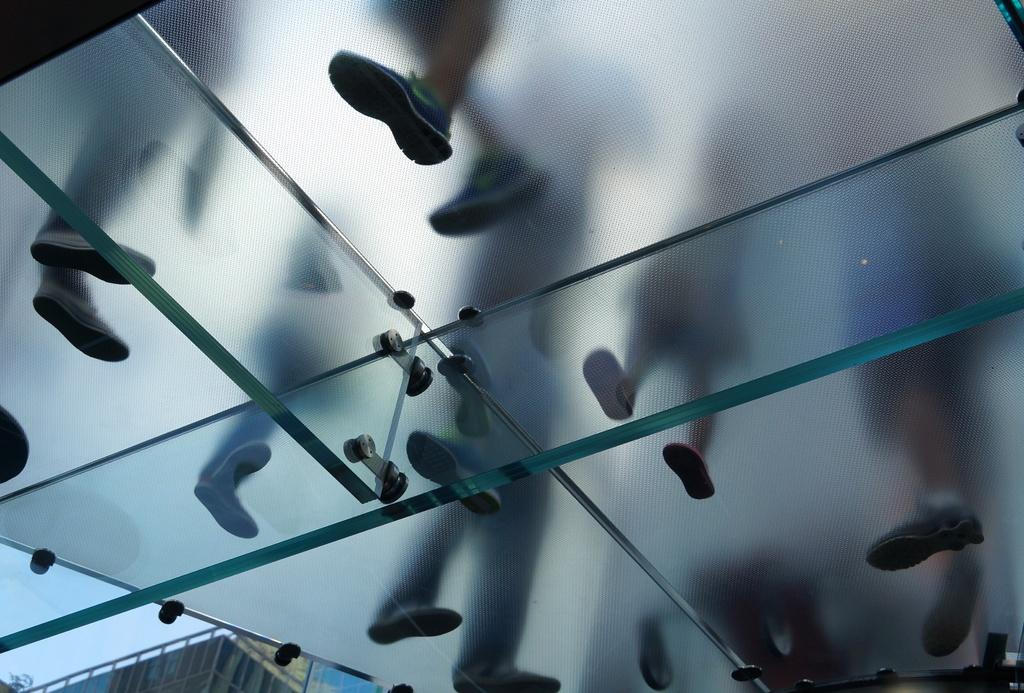What is on the glass in the image? There are persons' feet on the glass. What can be seen in the background of the image? There is a building and the sky visible in the background of the image. What type of jam is being spread on the giraffe in the image? There is no giraffe or jam present in the image. What type of tank is visible in the image? There is no tank present in the image. 